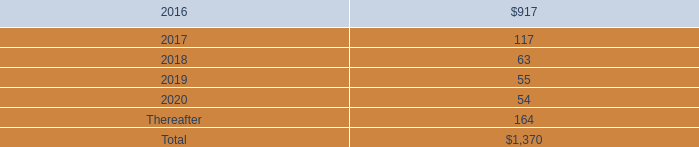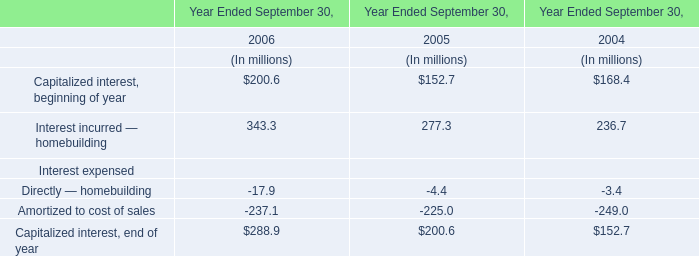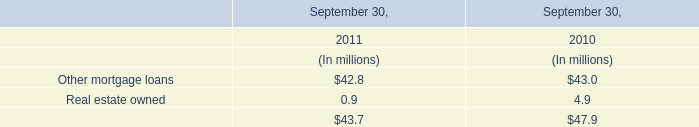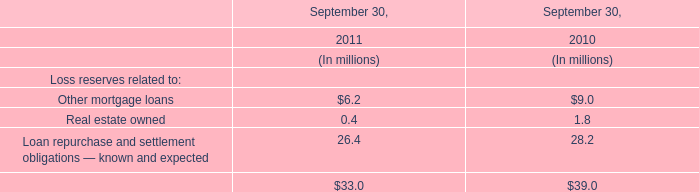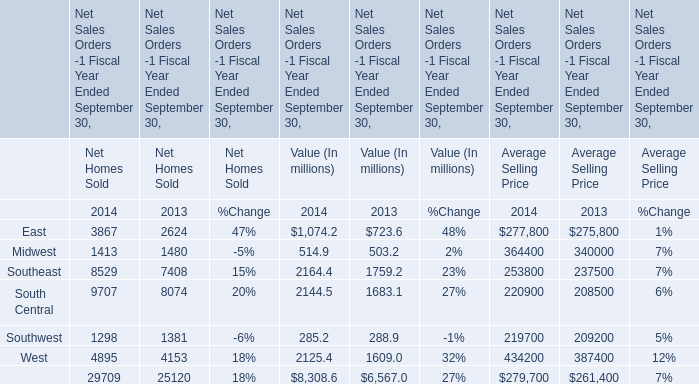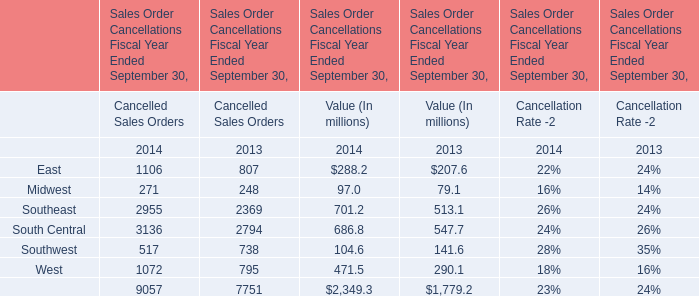What was the sum of Value (In millions) without those elements smaller than 500, in 2014? (in million) 
Computations: (701.2 + 686.8)
Answer: 1388.0. 